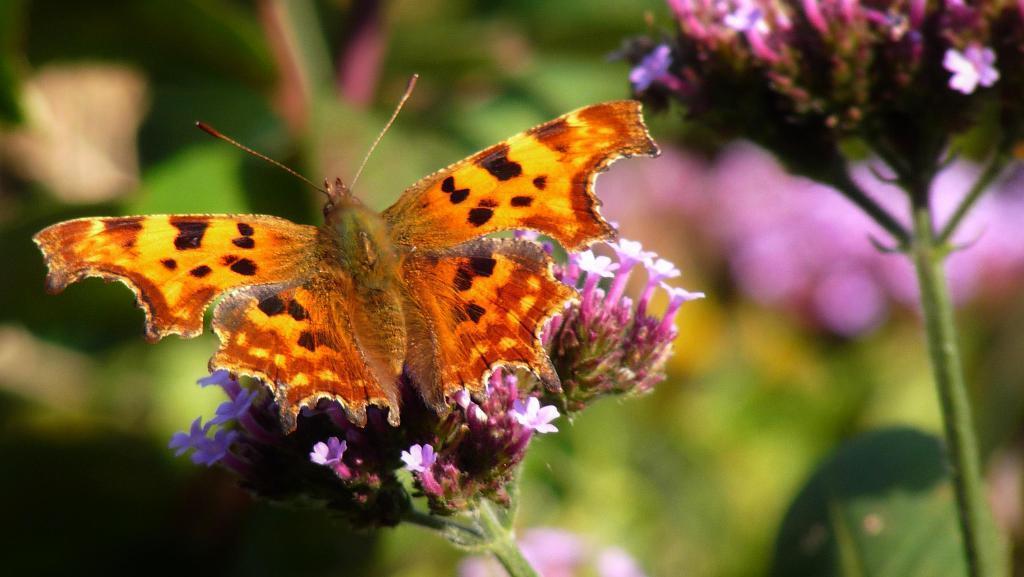Please provide a concise description of this image. In this image we can see many plants. There are many flowers to the plants. There is a butterfly on the plant in the image. There is a blur background in the image. 